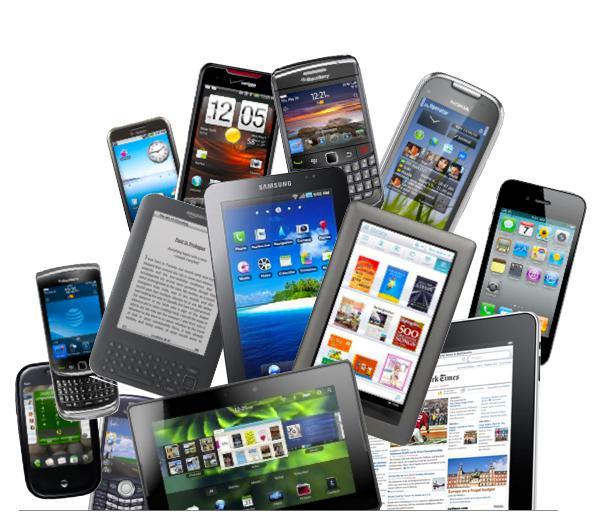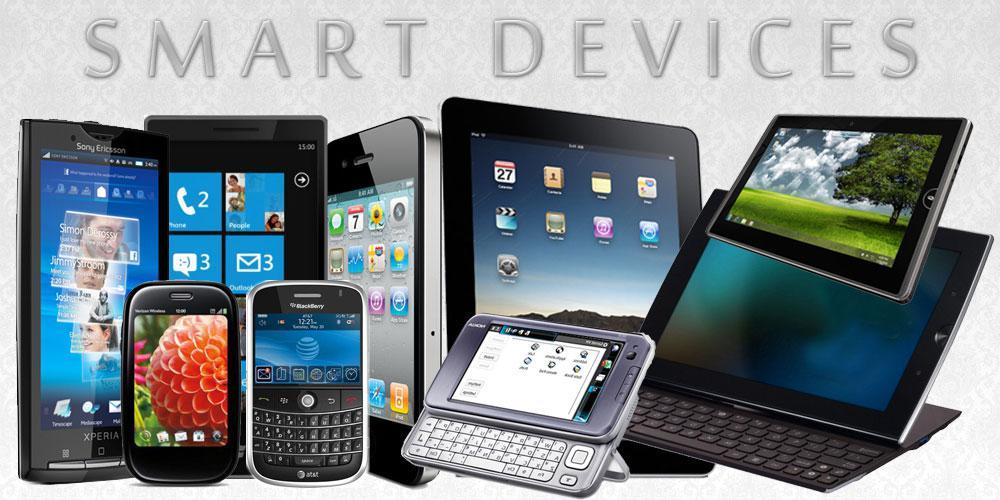The first image is the image on the left, the second image is the image on the right. For the images shown, is this caption "There are at least four devices visible in each image." true? Answer yes or no. Yes. The first image is the image on the left, the second image is the image on the right. For the images displayed, is the sentence "The left and right image contains the same number of laptops." factually correct? Answer yes or no. No. 